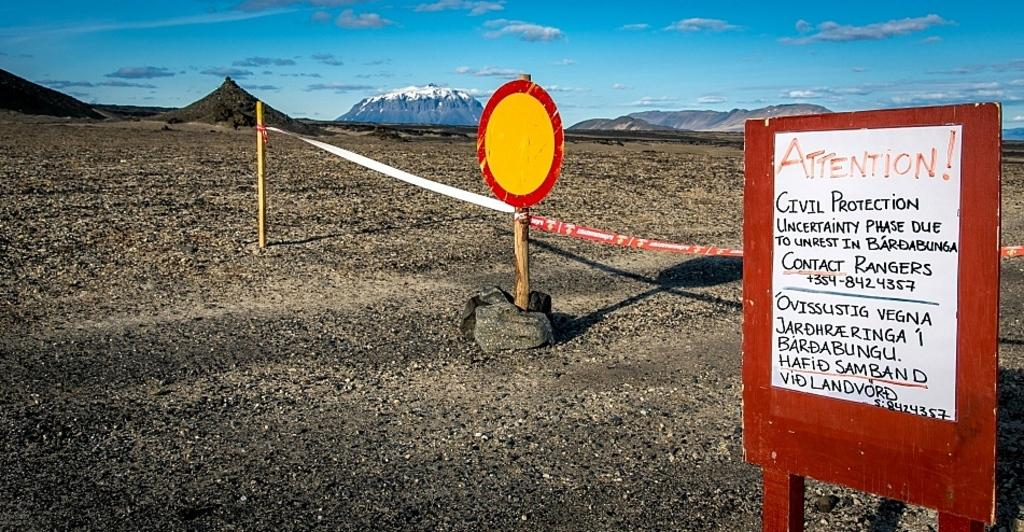<image>
Describe the image concisely. A barren gravel covered landscape near mountains with an Attention sign warning of civil protection uncertainty due to unrest in Bardabunga. 